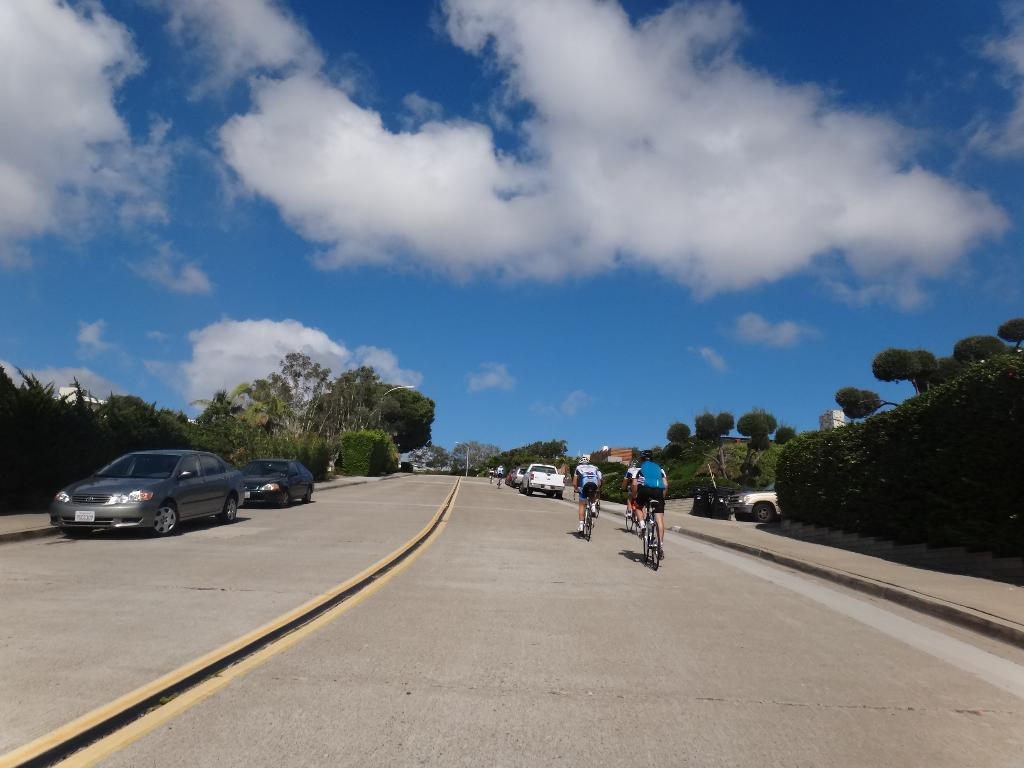What types of transportation can be seen on the road in the image? There are vehicles on the road in the image. What other mode of transportation can be seen on the road? There are people riding bicycles on the road. What can be seen on either side of the road? There are trees and buildings on either side of the road. What is visible in the sky in the background? There are clouds visible in the sky in the background. Where can the toothpaste be found in the image? There is no toothpaste present in the image. What type of air is visible in the image? The image does not show any specific type of air; it only shows clouds in the sky. 